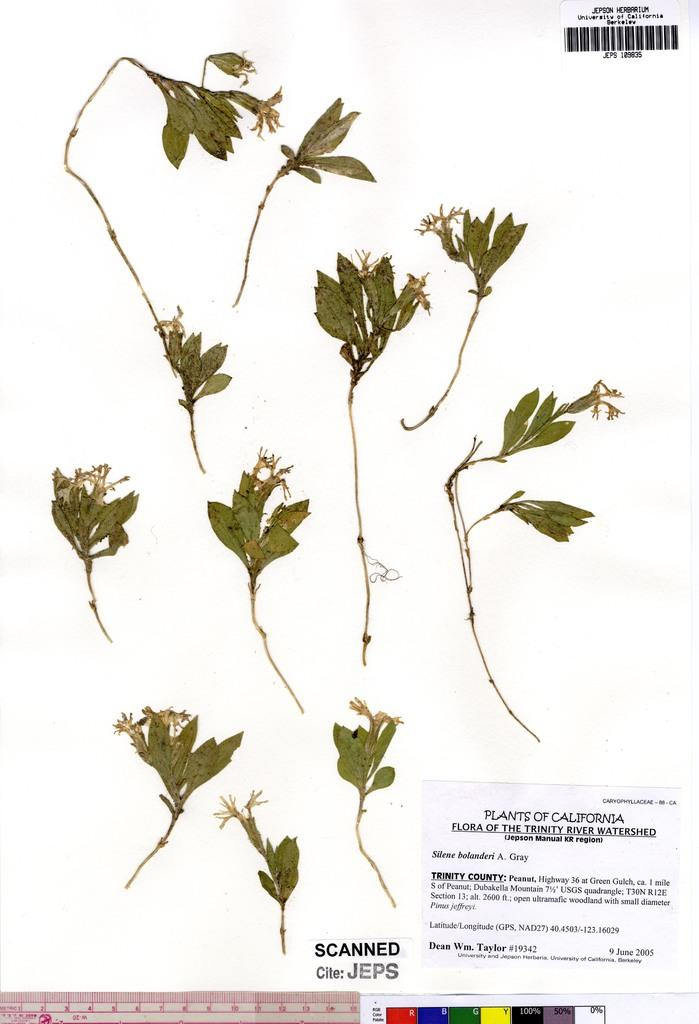What is the main object in the image? There is a white paper in the image. What is attached to the white paper? Plant samples are pasted on the paper. Is there any text or information on the paper? Yes, there is a note with some information at the bottom of the paper. What type of coast can be seen in the image? There is no coast visible in the image; it features a white paper with plant samples and a note. What hope does the image convey? The image does not convey any specific hope; it is a representation of a white paper with plant samples and a note. 